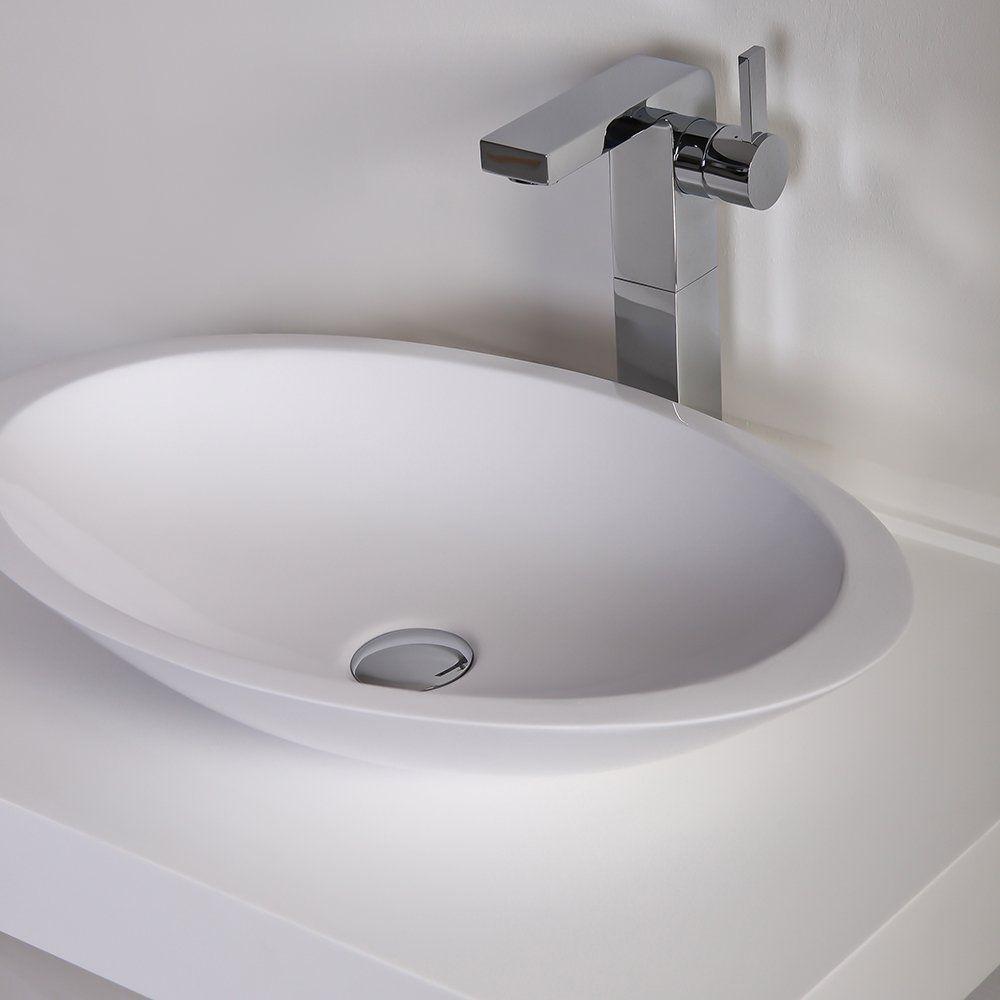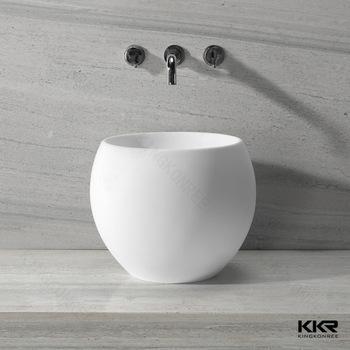The first image is the image on the left, the second image is the image on the right. For the images displayed, is the sentence "Each image shows a white bowl-shaped sink that sits on top of a counter." factually correct? Answer yes or no. Yes. 